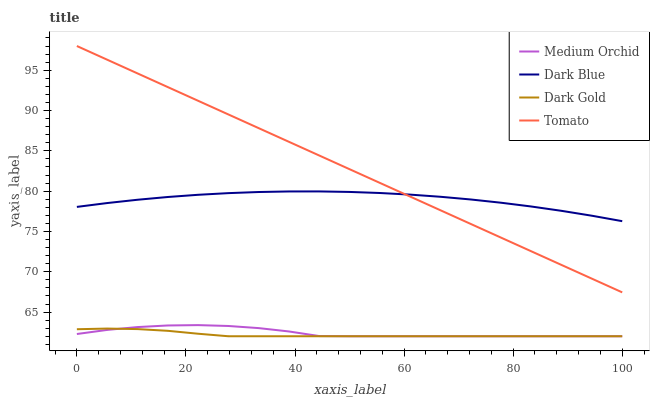Does Dark Gold have the minimum area under the curve?
Answer yes or no. Yes. Does Tomato have the maximum area under the curve?
Answer yes or no. Yes. Does Dark Blue have the minimum area under the curve?
Answer yes or no. No. Does Dark Blue have the maximum area under the curve?
Answer yes or no. No. Is Tomato the smoothest?
Answer yes or no. Yes. Is Medium Orchid the roughest?
Answer yes or no. Yes. Is Dark Blue the smoothest?
Answer yes or no. No. Is Dark Blue the roughest?
Answer yes or no. No. Does Medium Orchid have the lowest value?
Answer yes or no. Yes. Does Dark Blue have the lowest value?
Answer yes or no. No. Does Tomato have the highest value?
Answer yes or no. Yes. Does Dark Blue have the highest value?
Answer yes or no. No. Is Dark Gold less than Dark Blue?
Answer yes or no. Yes. Is Tomato greater than Medium Orchid?
Answer yes or no. Yes. Does Tomato intersect Dark Blue?
Answer yes or no. Yes. Is Tomato less than Dark Blue?
Answer yes or no. No. Is Tomato greater than Dark Blue?
Answer yes or no. No. Does Dark Gold intersect Dark Blue?
Answer yes or no. No. 